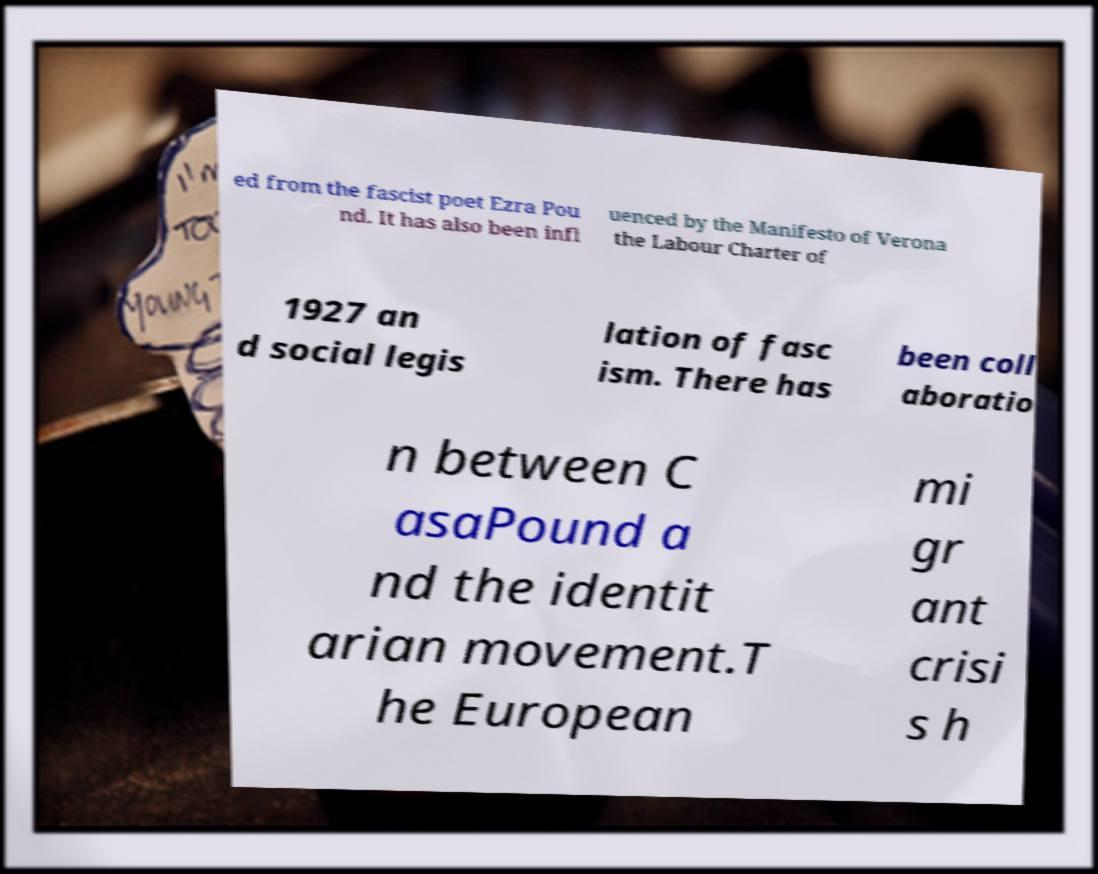I need the written content from this picture converted into text. Can you do that? ed from the fascist poet Ezra Pou nd. It has also been infl uenced by the Manifesto of Verona the Labour Charter of 1927 an d social legis lation of fasc ism. There has been coll aboratio n between C asaPound a nd the identit arian movement.T he European mi gr ant crisi s h 